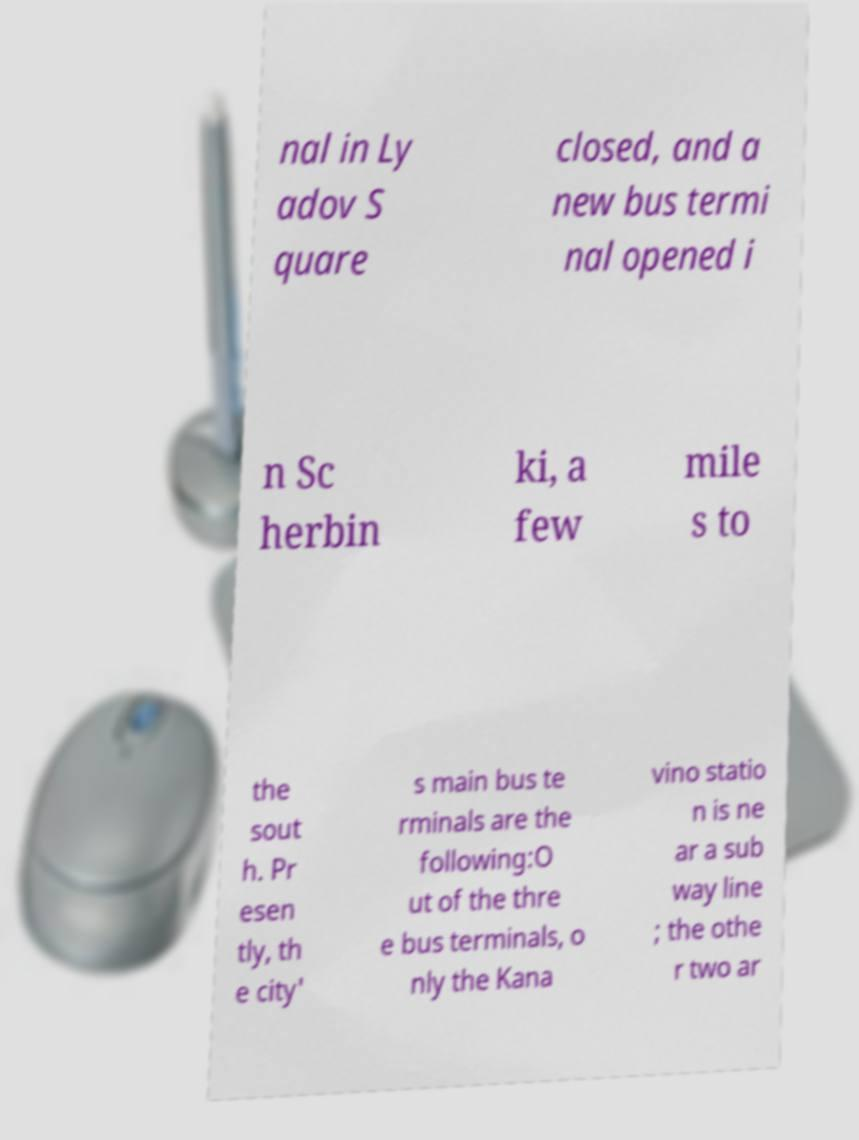Please identify and transcribe the text found in this image. nal in Ly adov S quare closed, and a new bus termi nal opened i n Sc herbin ki, a few mile s to the sout h. Pr esen tly, th e city' s main bus te rminals are the following:O ut of the thre e bus terminals, o nly the Kana vino statio n is ne ar a sub way line ; the othe r two ar 